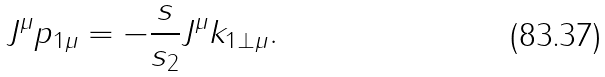Convert formula to latex. <formula><loc_0><loc_0><loc_500><loc_500>J ^ { \mu } p _ { 1 \mu } = - \frac { s } { s _ { 2 } } J ^ { \mu } k _ { 1 \bot \mu } .</formula> 